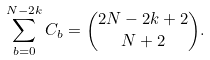<formula> <loc_0><loc_0><loc_500><loc_500>\sum _ { b = 0 } ^ { N - 2 k } C _ { b } = \binom { 2 N - 2 k + 2 } { N + 2 } .</formula> 